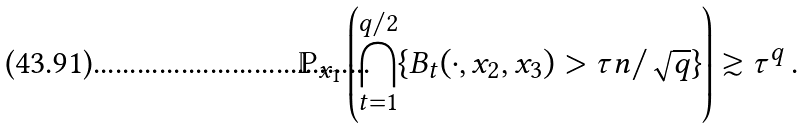Convert formula to latex. <formula><loc_0><loc_0><loc_500><loc_500>\mathbb { P } _ { x _ { 1 } } \left ( \bigcap _ { t = 1 } ^ { q / 2 } \{ B _ { t } ( \cdot , x _ { 2 } , x _ { 3 } ) > \tau n / \sqrt { q } \} \right ) \gtrsim \tau ^ { q } \, .</formula> 